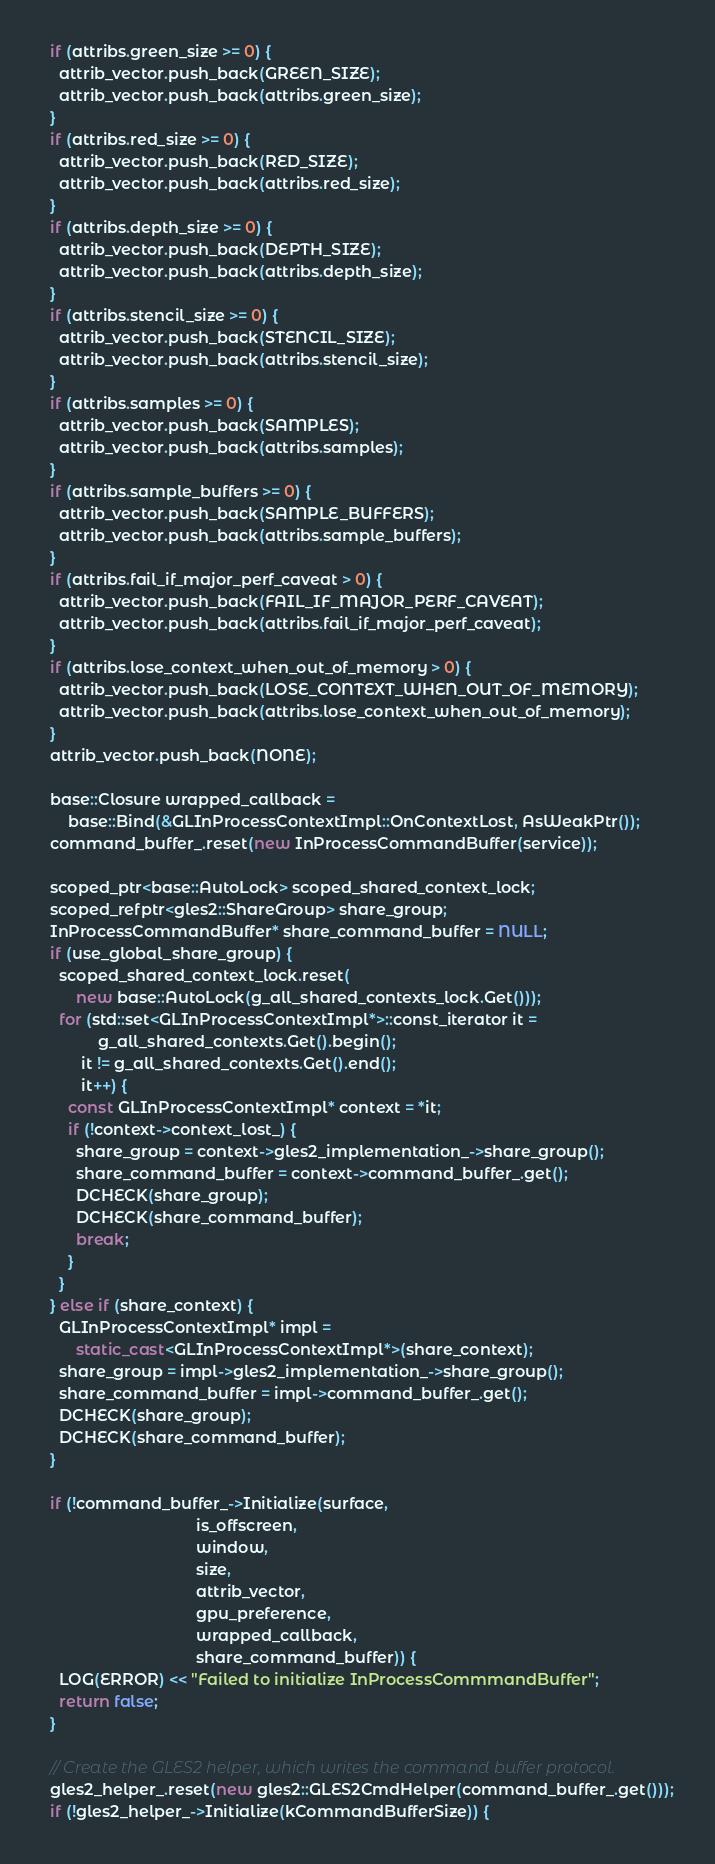<code> <loc_0><loc_0><loc_500><loc_500><_C++_>  if (attribs.green_size >= 0) {
    attrib_vector.push_back(GREEN_SIZE);
    attrib_vector.push_back(attribs.green_size);
  }
  if (attribs.red_size >= 0) {
    attrib_vector.push_back(RED_SIZE);
    attrib_vector.push_back(attribs.red_size);
  }
  if (attribs.depth_size >= 0) {
    attrib_vector.push_back(DEPTH_SIZE);
    attrib_vector.push_back(attribs.depth_size);
  }
  if (attribs.stencil_size >= 0) {
    attrib_vector.push_back(STENCIL_SIZE);
    attrib_vector.push_back(attribs.stencil_size);
  }
  if (attribs.samples >= 0) {
    attrib_vector.push_back(SAMPLES);
    attrib_vector.push_back(attribs.samples);
  }
  if (attribs.sample_buffers >= 0) {
    attrib_vector.push_back(SAMPLE_BUFFERS);
    attrib_vector.push_back(attribs.sample_buffers);
  }
  if (attribs.fail_if_major_perf_caveat > 0) {
    attrib_vector.push_back(FAIL_IF_MAJOR_PERF_CAVEAT);
    attrib_vector.push_back(attribs.fail_if_major_perf_caveat);
  }
  if (attribs.lose_context_when_out_of_memory > 0) {
    attrib_vector.push_back(LOSE_CONTEXT_WHEN_OUT_OF_MEMORY);
    attrib_vector.push_back(attribs.lose_context_when_out_of_memory);
  }
  attrib_vector.push_back(NONE);

  base::Closure wrapped_callback =
      base::Bind(&GLInProcessContextImpl::OnContextLost, AsWeakPtr());
  command_buffer_.reset(new InProcessCommandBuffer(service));

  scoped_ptr<base::AutoLock> scoped_shared_context_lock;
  scoped_refptr<gles2::ShareGroup> share_group;
  InProcessCommandBuffer* share_command_buffer = NULL;
  if (use_global_share_group) {
    scoped_shared_context_lock.reset(
        new base::AutoLock(g_all_shared_contexts_lock.Get()));
    for (std::set<GLInProcessContextImpl*>::const_iterator it =
             g_all_shared_contexts.Get().begin();
         it != g_all_shared_contexts.Get().end();
         it++) {
      const GLInProcessContextImpl* context = *it;
      if (!context->context_lost_) {
        share_group = context->gles2_implementation_->share_group();
        share_command_buffer = context->command_buffer_.get();
        DCHECK(share_group);
        DCHECK(share_command_buffer);
        break;
      }
    }
  } else if (share_context) {
    GLInProcessContextImpl* impl =
        static_cast<GLInProcessContextImpl*>(share_context);
    share_group = impl->gles2_implementation_->share_group();
    share_command_buffer = impl->command_buffer_.get();
    DCHECK(share_group);
    DCHECK(share_command_buffer);
  }

  if (!command_buffer_->Initialize(surface,
                                   is_offscreen,
                                   window,
                                   size,
                                   attrib_vector,
                                   gpu_preference,
                                   wrapped_callback,
                                   share_command_buffer)) {
    LOG(ERROR) << "Failed to initialize InProcessCommmandBuffer";
    return false;
  }

  // Create the GLES2 helper, which writes the command buffer protocol.
  gles2_helper_.reset(new gles2::GLES2CmdHelper(command_buffer_.get()));
  if (!gles2_helper_->Initialize(kCommandBufferSize)) {</code> 